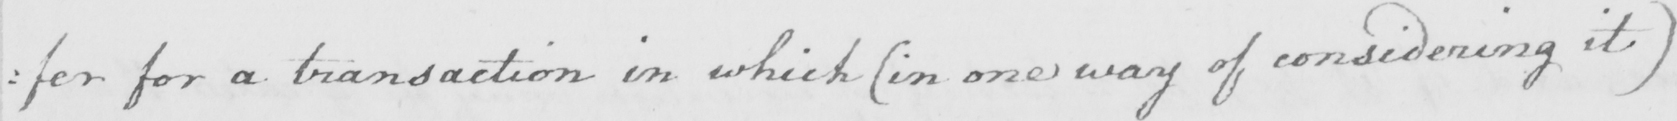Can you read and transcribe this handwriting? : fer for a transaction in which  ( in one way of considering it ) 